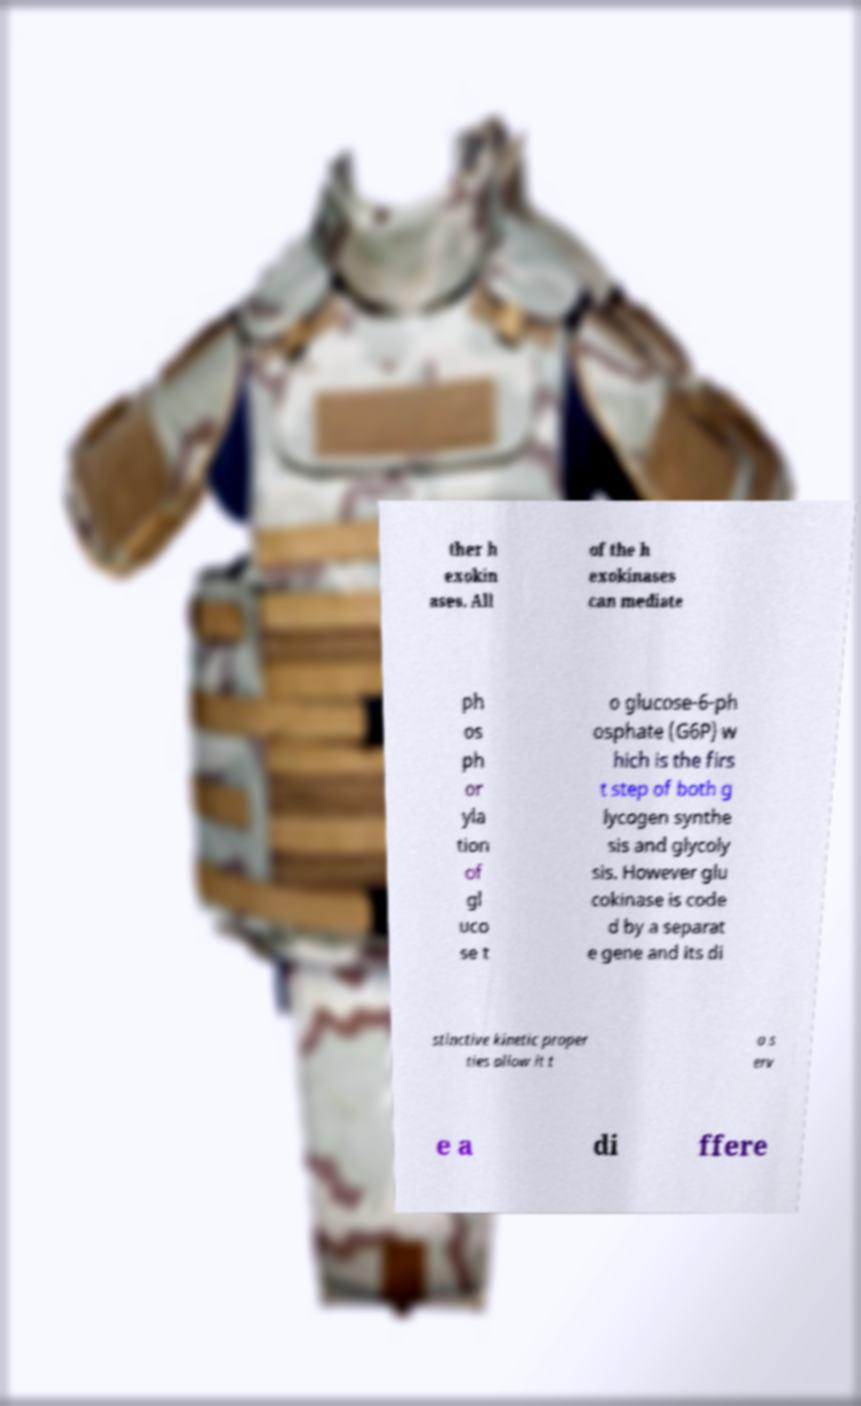Please read and relay the text visible in this image. What does it say? ther h exokin ases. All of the h exokinases can mediate ph os ph or yla tion of gl uco se t o glucose-6-ph osphate (G6P) w hich is the firs t step of both g lycogen synthe sis and glycoly sis. However glu cokinase is code d by a separat e gene and its di stinctive kinetic proper ties allow it t o s erv e a di ffere 